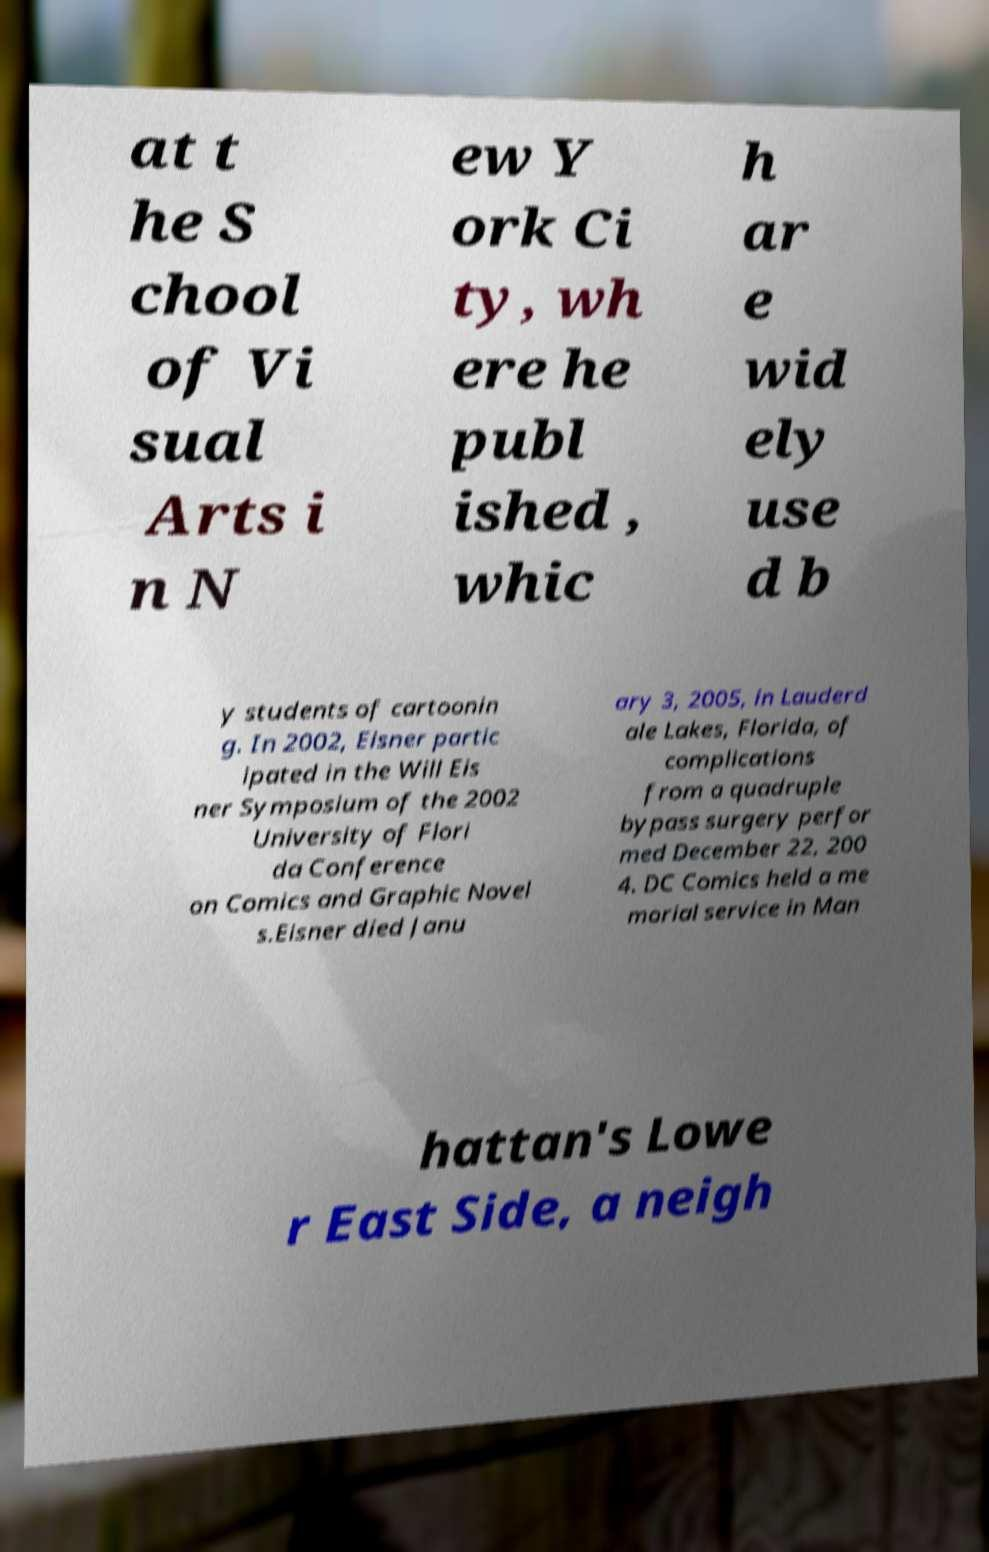For documentation purposes, I need the text within this image transcribed. Could you provide that? at t he S chool of Vi sual Arts i n N ew Y ork Ci ty, wh ere he publ ished , whic h ar e wid ely use d b y students of cartoonin g. In 2002, Eisner partic ipated in the Will Eis ner Symposium of the 2002 University of Flori da Conference on Comics and Graphic Novel s.Eisner died Janu ary 3, 2005, in Lauderd ale Lakes, Florida, of complications from a quadruple bypass surgery perfor med December 22, 200 4. DC Comics held a me morial service in Man hattan's Lowe r East Side, a neigh 